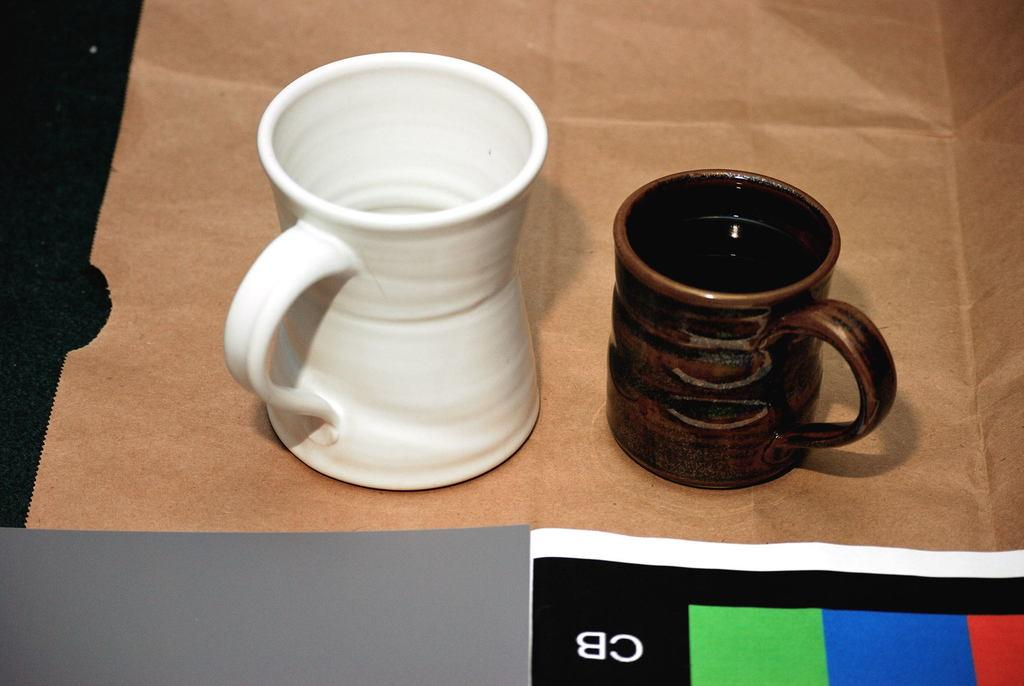<image>
Relay a brief, clear account of the picture shown. Two coffe mugs sit on a table in front of a sheet of paper that says CB 